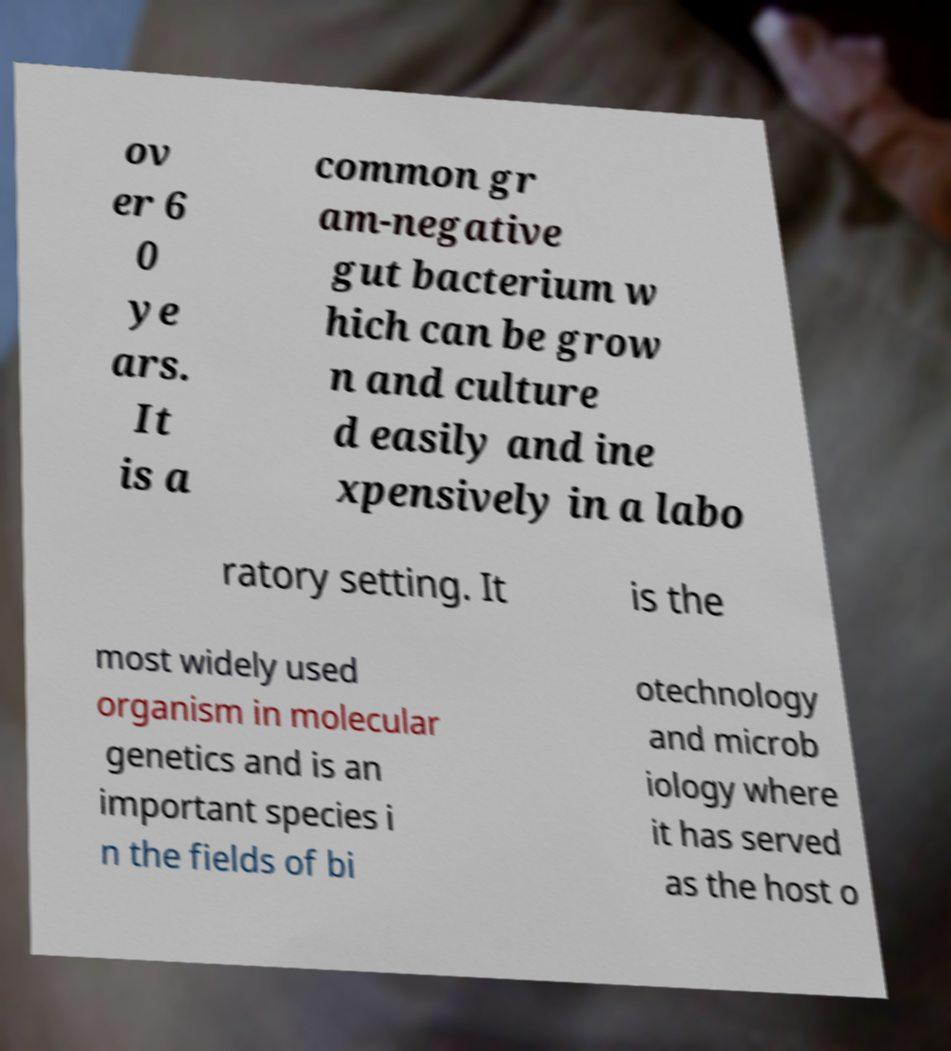What messages or text are displayed in this image? I need them in a readable, typed format. ov er 6 0 ye ars. It is a common gr am-negative gut bacterium w hich can be grow n and culture d easily and ine xpensively in a labo ratory setting. It is the most widely used organism in molecular genetics and is an important species i n the fields of bi otechnology and microb iology where it has served as the host o 